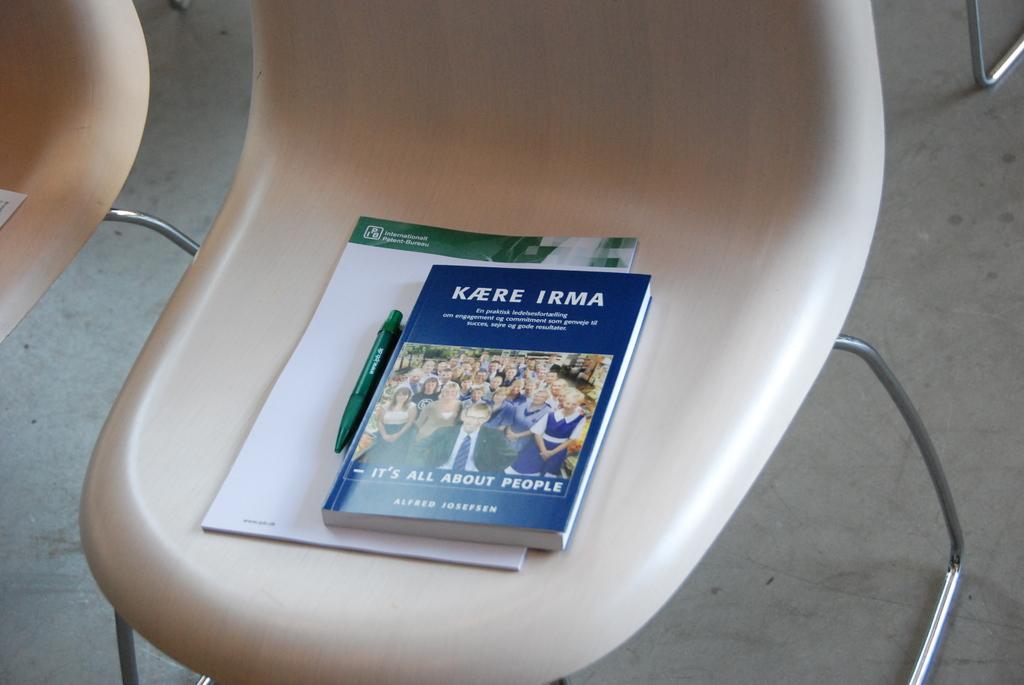What is the subject of the book with the blue cover?
Keep it short and to the point. People. What does it say at the very top of this pamphlet?
Offer a terse response. Kaere irma. 